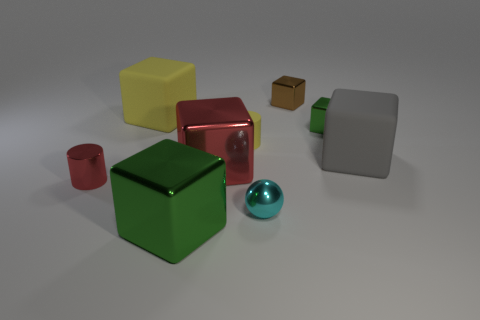Subtract 1 cubes. How many cubes are left? 5 Subtract all large gray rubber blocks. How many blocks are left? 5 Subtract all red cubes. How many cubes are left? 5 Subtract all red blocks. Subtract all purple cylinders. How many blocks are left? 5 Add 1 large things. How many objects exist? 10 Subtract all cylinders. How many objects are left? 7 Subtract 0 cyan cylinders. How many objects are left? 9 Subtract all green cylinders. Subtract all metallic cylinders. How many objects are left? 8 Add 4 red cylinders. How many red cylinders are left? 5 Add 5 large objects. How many large objects exist? 9 